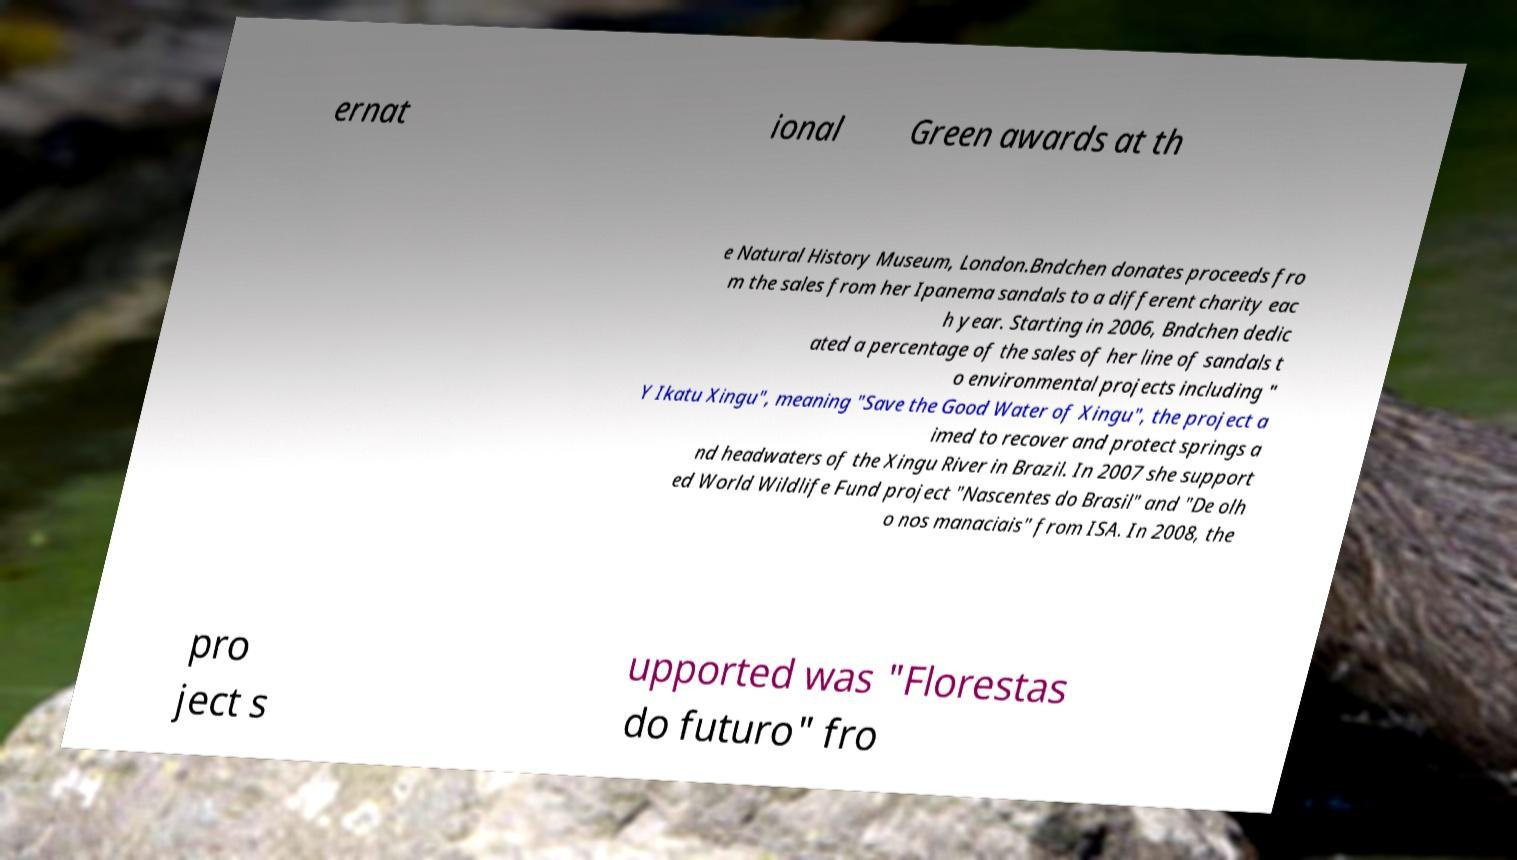Can you accurately transcribe the text from the provided image for me? ernat ional Green awards at th e Natural History Museum, London.Bndchen donates proceeds fro m the sales from her Ipanema sandals to a different charity eac h year. Starting in 2006, Bndchen dedic ated a percentage of the sales of her line of sandals t o environmental projects including " Y Ikatu Xingu", meaning "Save the Good Water of Xingu", the project a imed to recover and protect springs a nd headwaters of the Xingu River in Brazil. In 2007 she support ed World Wildlife Fund project "Nascentes do Brasil" and "De olh o nos manaciais" from ISA. In 2008, the pro ject s upported was "Florestas do futuro" fro 